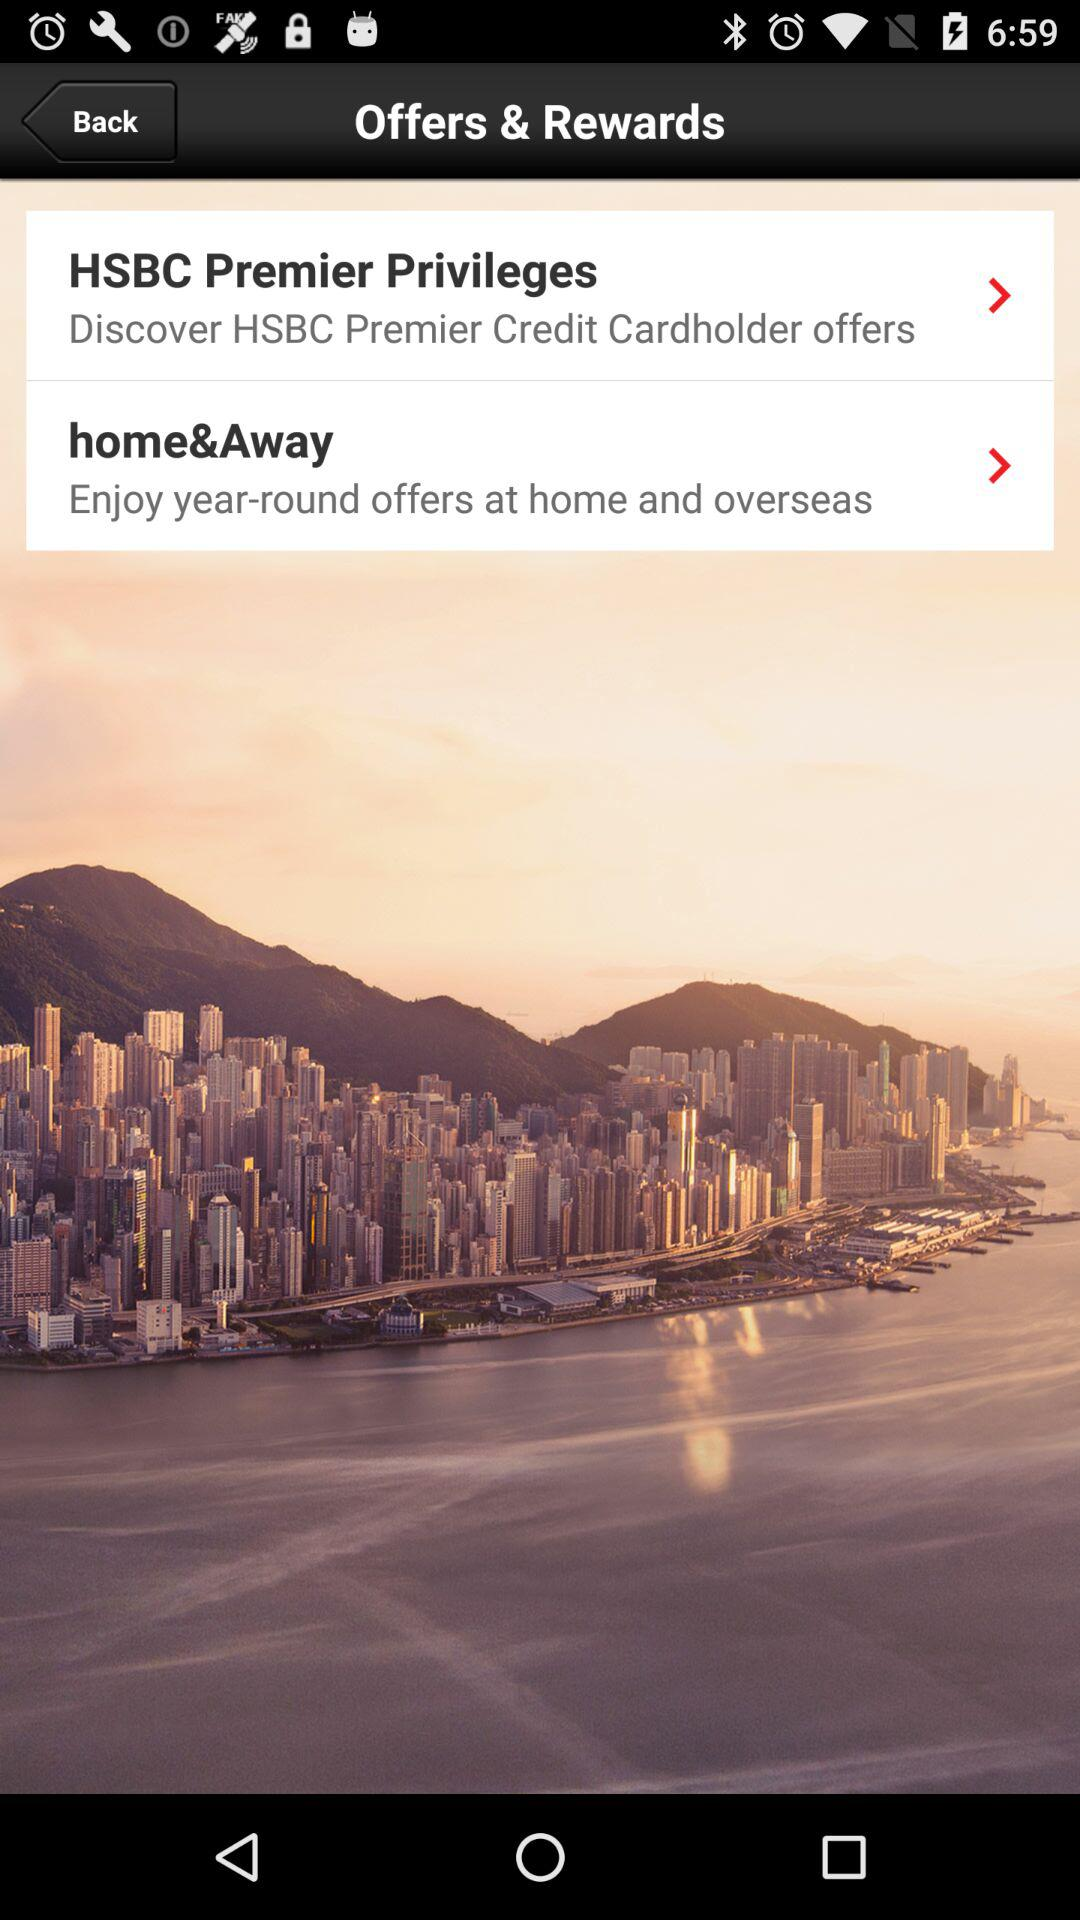How many HSBC offers are there?
Answer the question using a single word or phrase. 2 